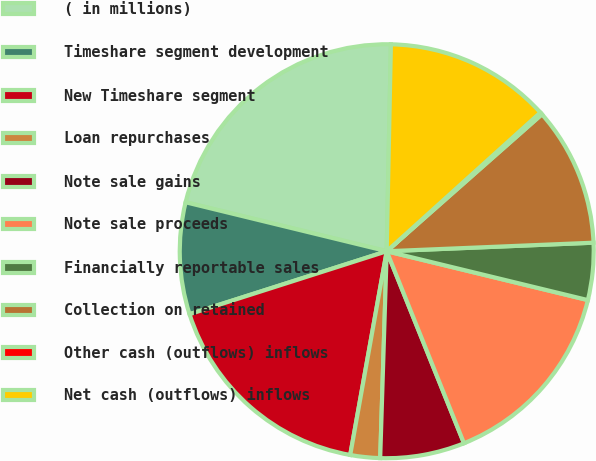<chart> <loc_0><loc_0><loc_500><loc_500><pie_chart><fcel>( in millions)<fcel>Timeshare segment development<fcel>New Timeshare segment<fcel>Loan repurchases<fcel>Note sale gains<fcel>Note sale proceeds<fcel>Financially reportable sales<fcel>Collection on retained<fcel>Other cash (outflows) inflows<fcel>Net cash (outflows) inflows<nl><fcel>21.52%<fcel>8.72%<fcel>17.26%<fcel>2.32%<fcel>6.59%<fcel>15.12%<fcel>4.45%<fcel>10.85%<fcel>0.18%<fcel>12.99%<nl></chart> 